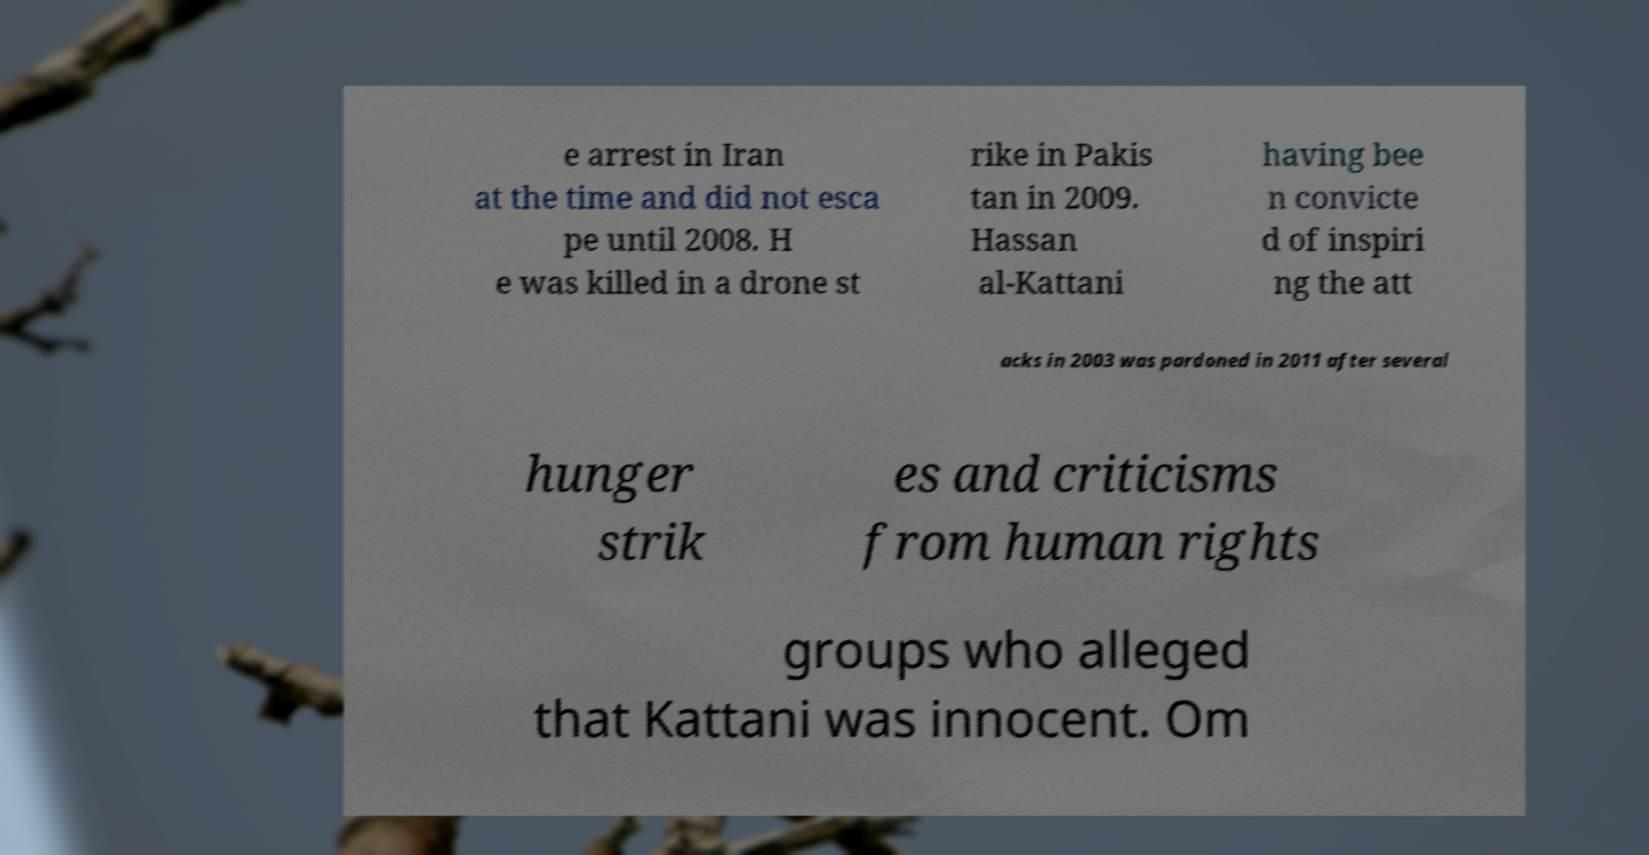Could you assist in decoding the text presented in this image and type it out clearly? e arrest in Iran at the time and did not esca pe until 2008. H e was killed in a drone st rike in Pakis tan in 2009. Hassan al-Kattani having bee n convicte d of inspiri ng the att acks in 2003 was pardoned in 2011 after several hunger strik es and criticisms from human rights groups who alleged that Kattani was innocent. Om 